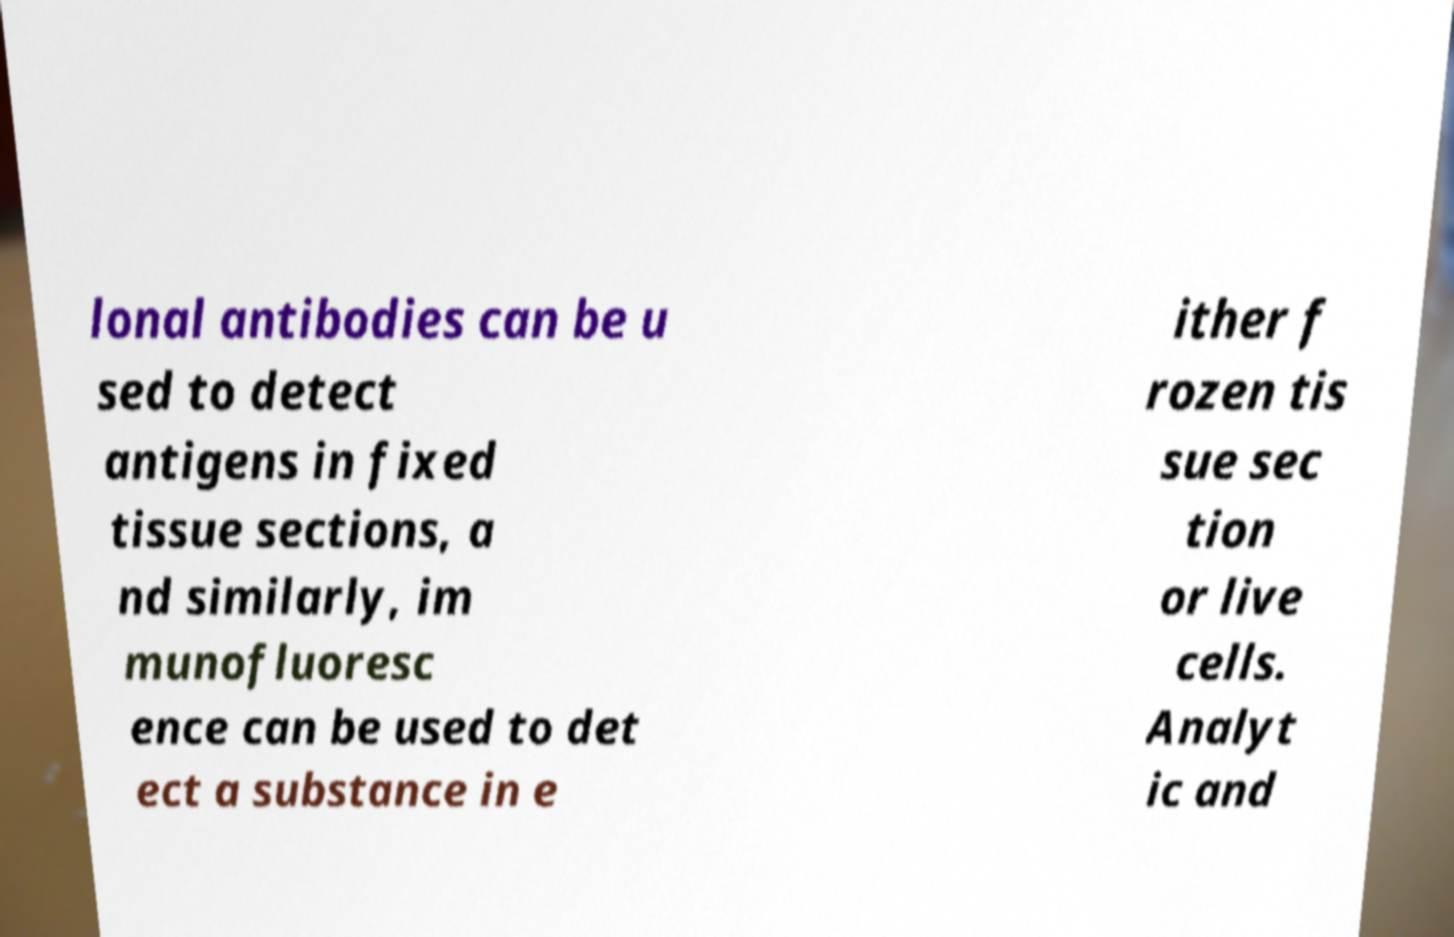Can you accurately transcribe the text from the provided image for me? lonal antibodies can be u sed to detect antigens in fixed tissue sections, a nd similarly, im munofluoresc ence can be used to det ect a substance in e ither f rozen tis sue sec tion or live cells. Analyt ic and 